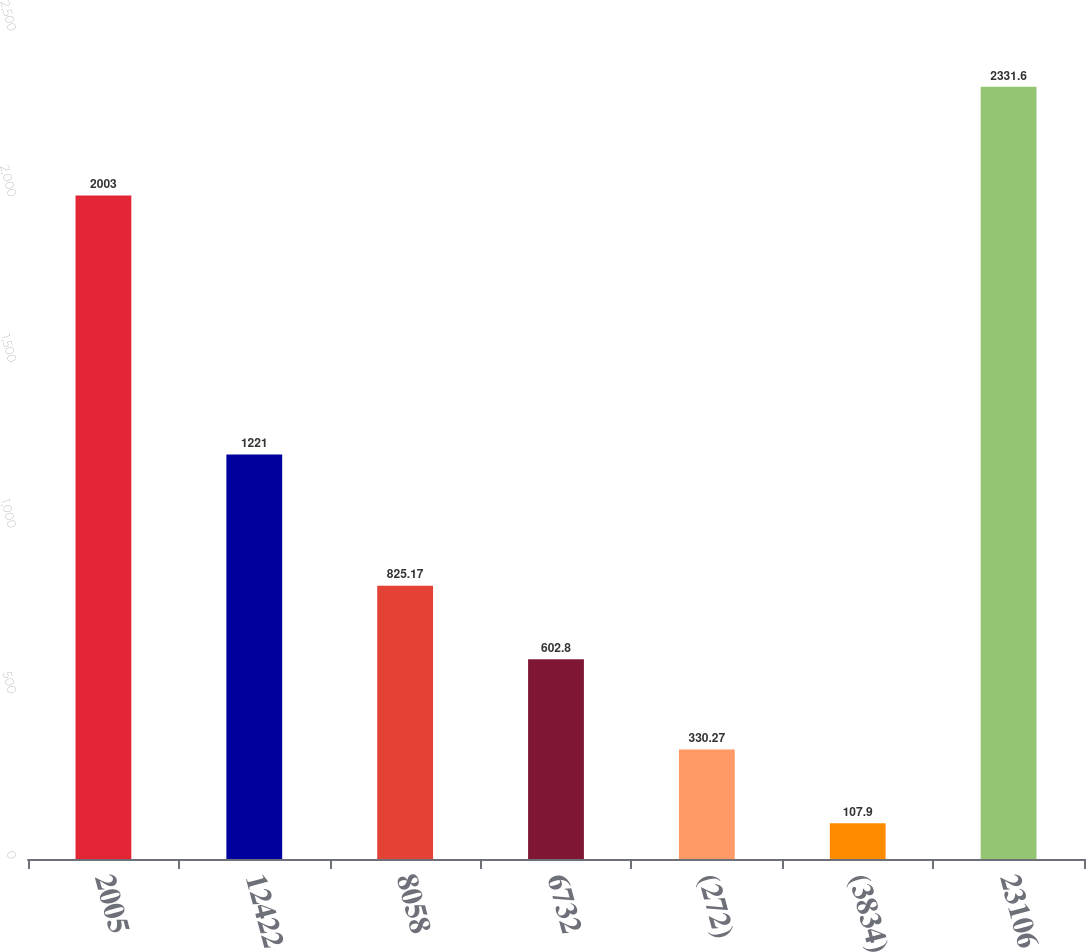Convert chart. <chart><loc_0><loc_0><loc_500><loc_500><bar_chart><fcel>2005<fcel>12422<fcel>8058<fcel>6732<fcel>(272)<fcel>(3834)<fcel>23106<nl><fcel>2003<fcel>1221<fcel>825.17<fcel>602.8<fcel>330.27<fcel>107.9<fcel>2331.6<nl></chart> 